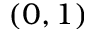<formula> <loc_0><loc_0><loc_500><loc_500>( 0 , 1 )</formula> 